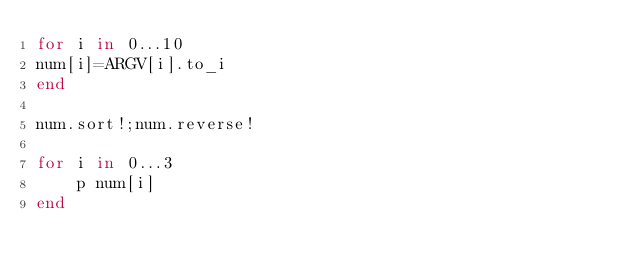<code> <loc_0><loc_0><loc_500><loc_500><_Ruby_>for i in 0...10
num[i]=ARGV[i].to_i
end

num.sort!;num.reverse!

for i in 0...3
    p num[i]
end</code> 